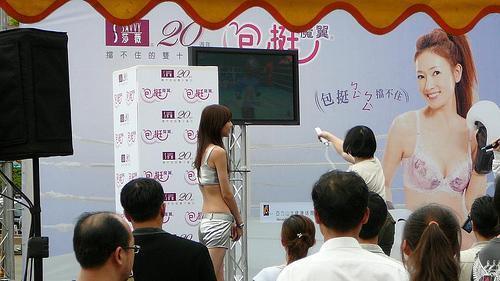How many people are there?
Give a very brief answer. 7. 